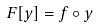<formula> <loc_0><loc_0><loc_500><loc_500>F [ y ] = f \circ y</formula> 